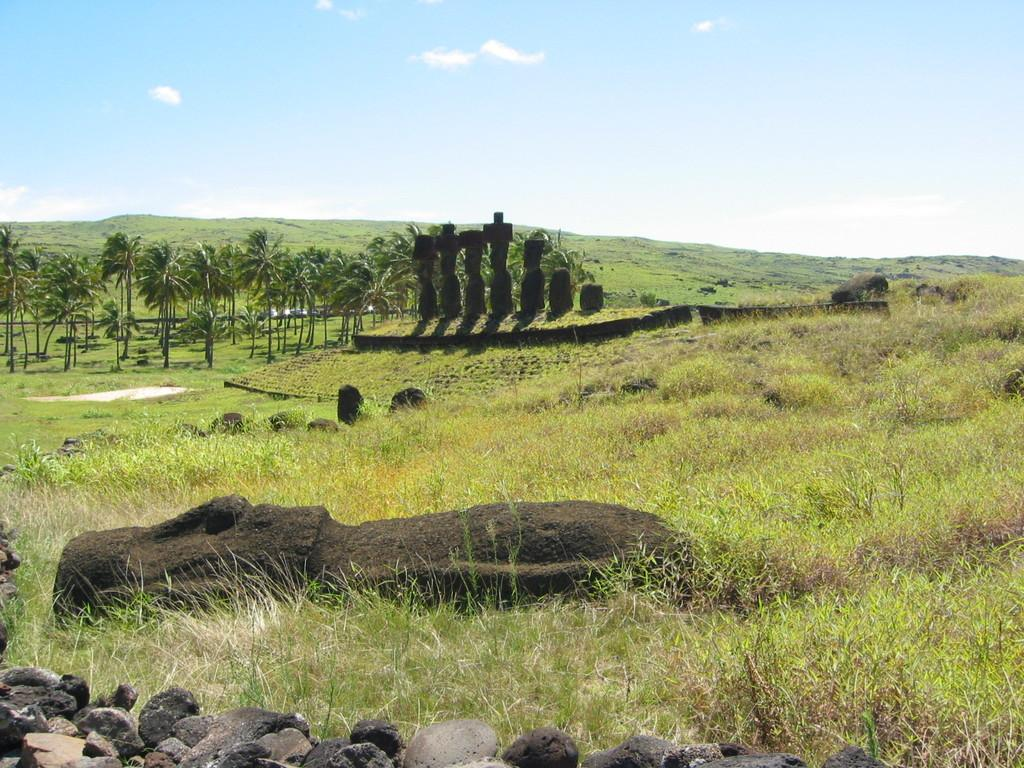What is located in the center of the image? There are trees, stones, and grass in the center of the image. What can be seen in the background of the image? The sky, clouds, and a hill are visible in the background of the image. Who is the owner of the swing in the image? There is no swing present in the image. What type of basket is being used to collect the apples from the trees in the image? There are no apples or baskets present in the image. 